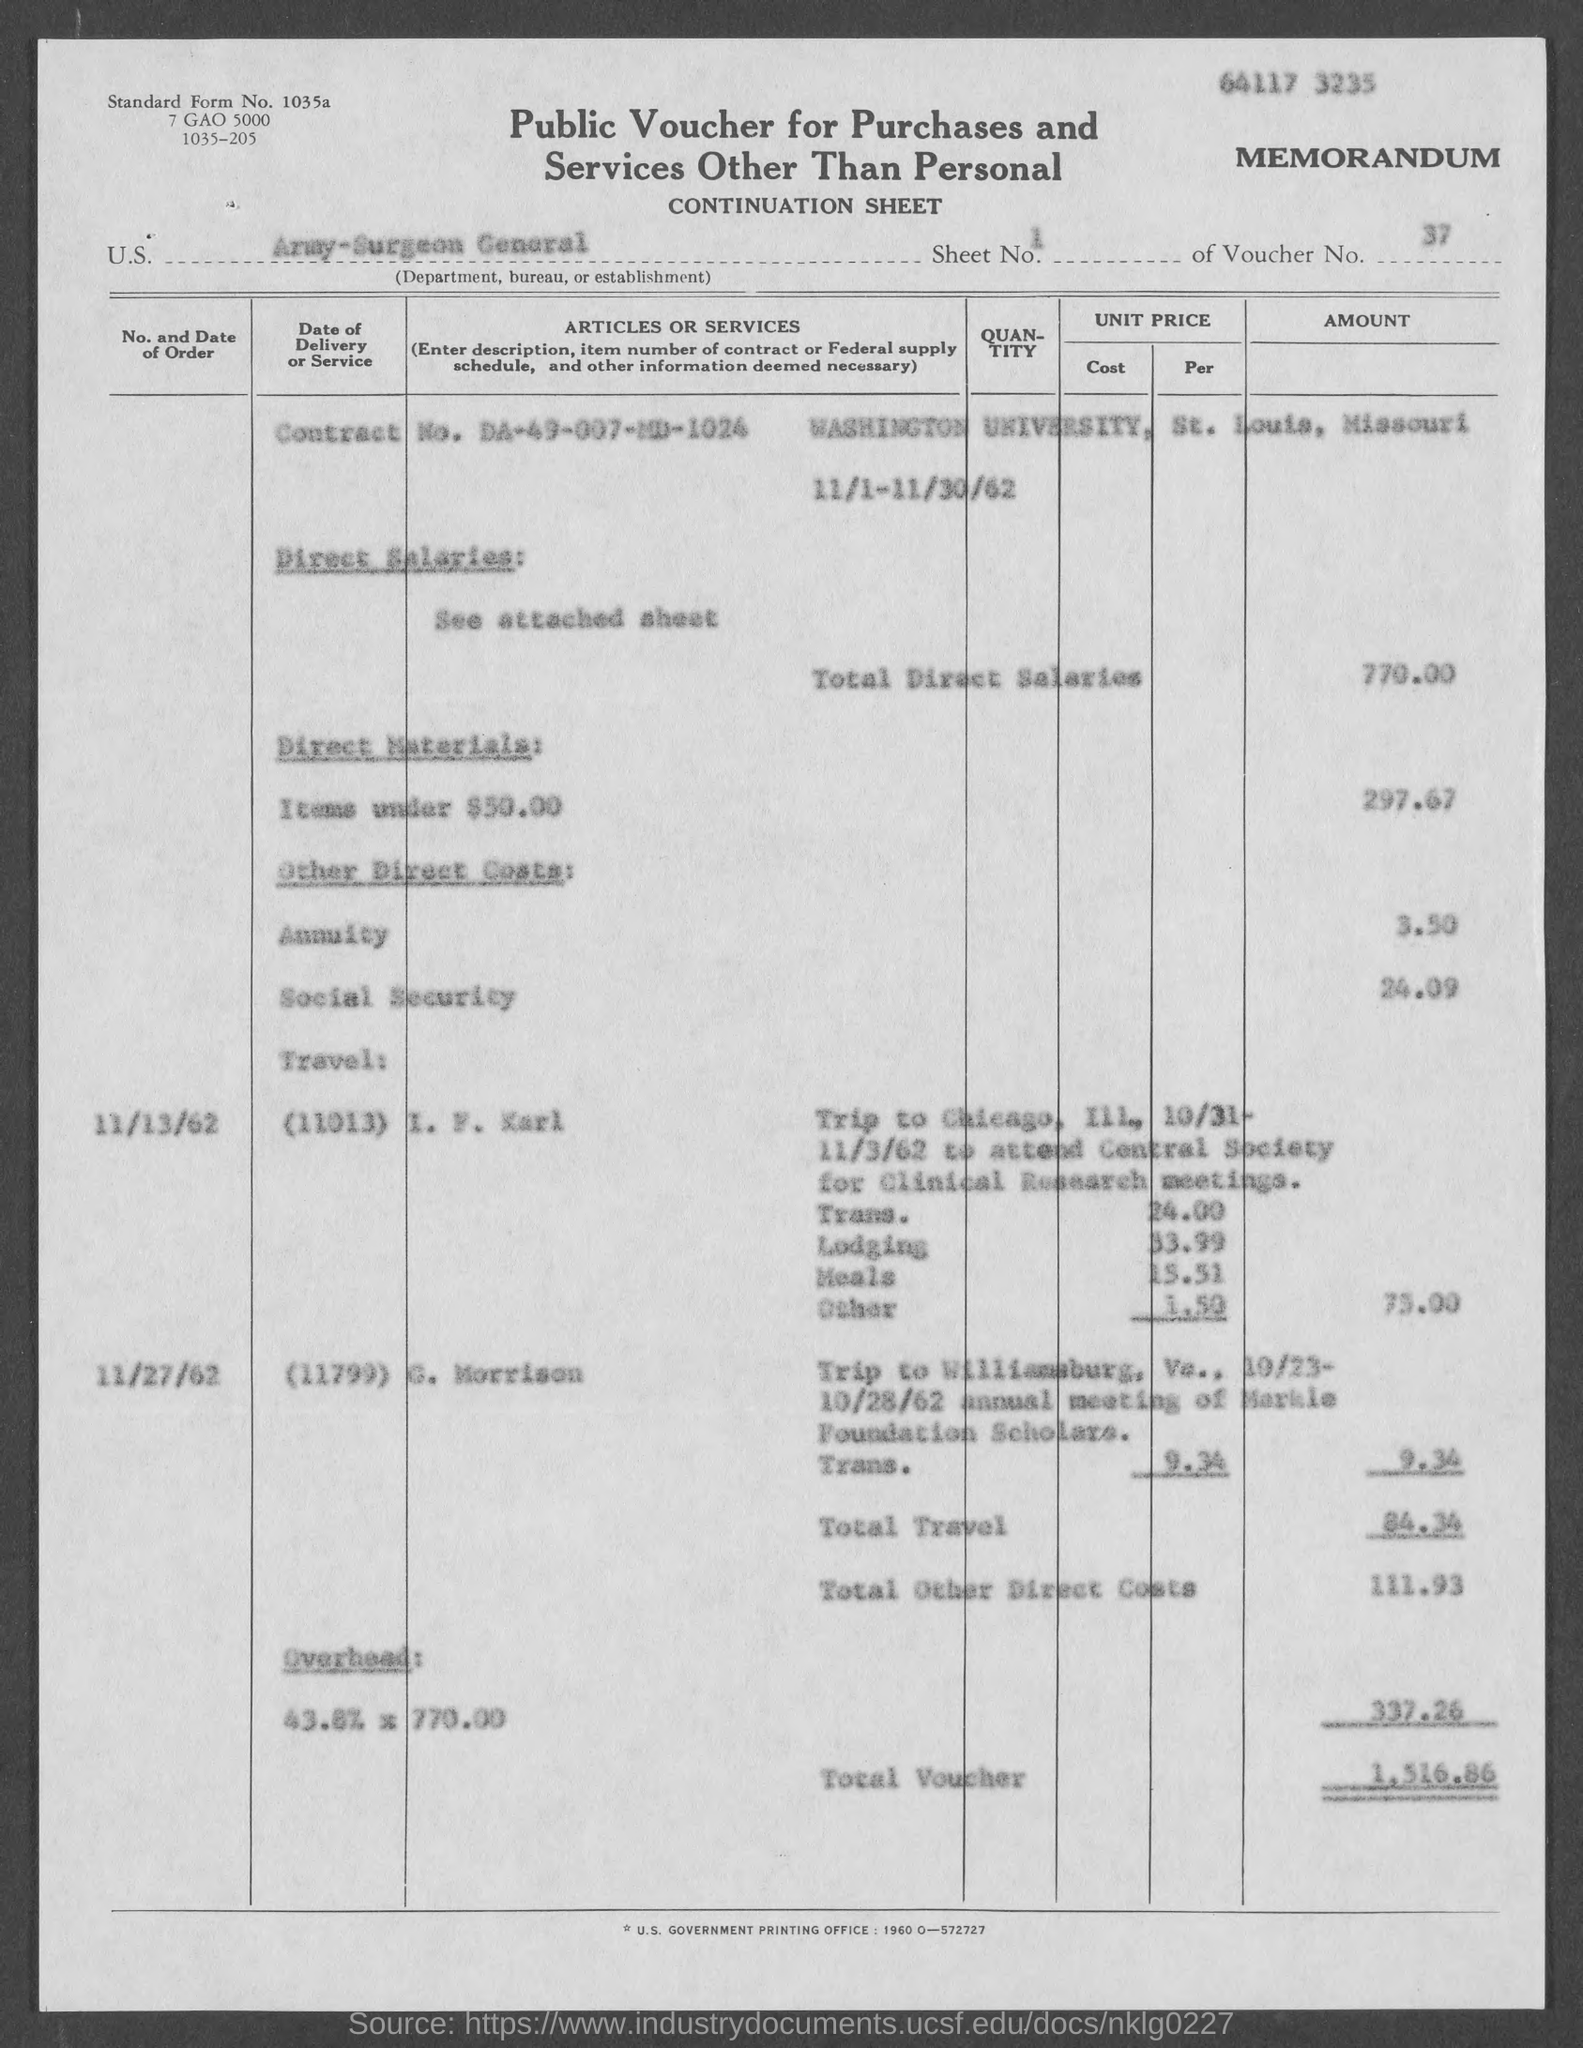What details are provided about the Trip to Williamsburg? The trip to Williamsburg is detailed with a charge of $9.24 for transportation. It was taken by 'L. Morrison' on 10/25-10/28/62 for the annual meeting of 'Sirle Foundation Sclerosis.' 